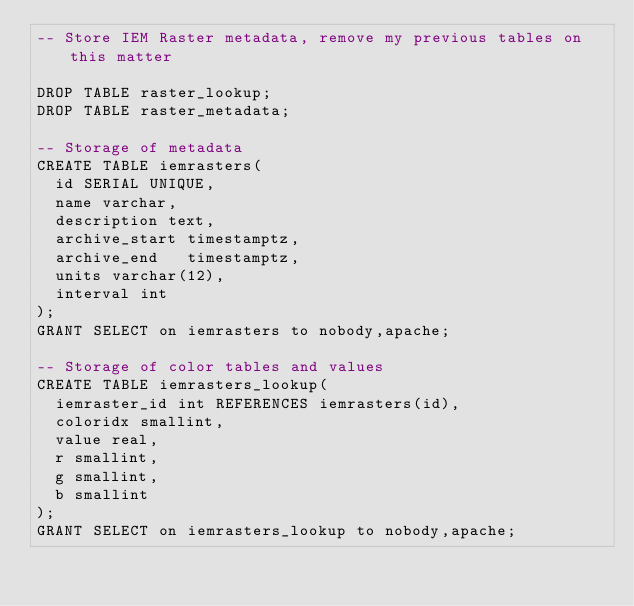<code> <loc_0><loc_0><loc_500><loc_500><_SQL_>-- Store IEM Raster metadata, remove my previous tables on this matter

DROP TABLE raster_lookup;
DROP TABLE raster_metadata;

-- Storage of metadata
CREATE TABLE iemrasters(
  id SERIAL UNIQUE,
  name varchar,
  description text,
  archive_start timestamptz,
  archive_end   timestamptz,
  units varchar(12),
  interval int
);
GRANT SELECT on iemrasters to nobody,apache;

-- Storage of color tables and values
CREATE TABLE iemrasters_lookup(
  iemraster_id int REFERENCES iemrasters(id),
  coloridx smallint,
  value real,
  r smallint,
  g smallint,
  b smallint
);
GRANT SELECT on iemrasters_lookup to nobody,apache;</code> 